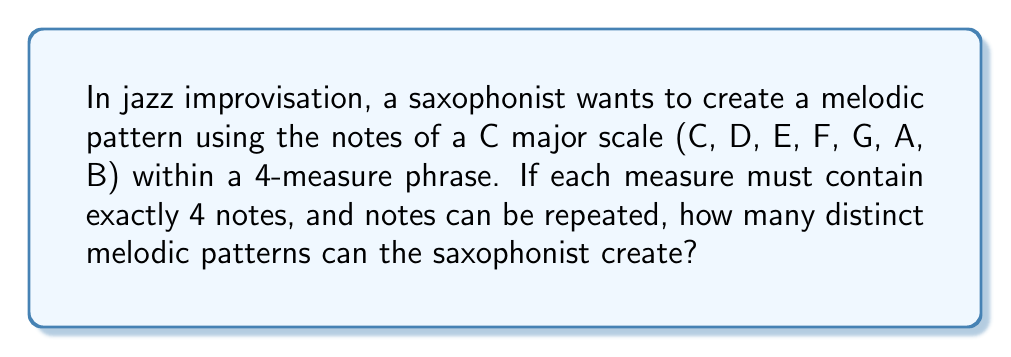Could you help me with this problem? Let's approach this step-by-step:

1) First, we need to understand what we're counting:
   - We have 7 possible notes to choose from (C, D, E, F, G, A, B)
   - We need to fill 4 measures
   - Each measure contains 4 notes
   - Notes can be repeated

2) This scenario is a perfect example of the multiplication principle in combinatorics.

3) For each note position, we have 7 choices (any of the 7 notes of the C major scale).

4) We have 4 notes per measure, and 4 measures in total. So, we need to make 16 independent choices (4 × 4 = 16).

5) According to the multiplication principle, if we have n independent events, and each event has m possible outcomes, the total number of possible outcomes is $m^n$.

6) In this case:
   - m = 7 (7 possible notes for each choice)
   - n = 16 (16 total note choices to make)

7) Therefore, the total number of distinct melodic patterns is:

   $$ 7^{16} $$

8) Calculating this:
   $$ 7^{16} = 33,232,930,569,601 $$

This enormous number showcases the vast possibilities available to a jazz improviser, even within a relatively short 4-measure phrase using only the notes of a major scale.
Answer: $7^{16} = 33,232,930,569,601$ 